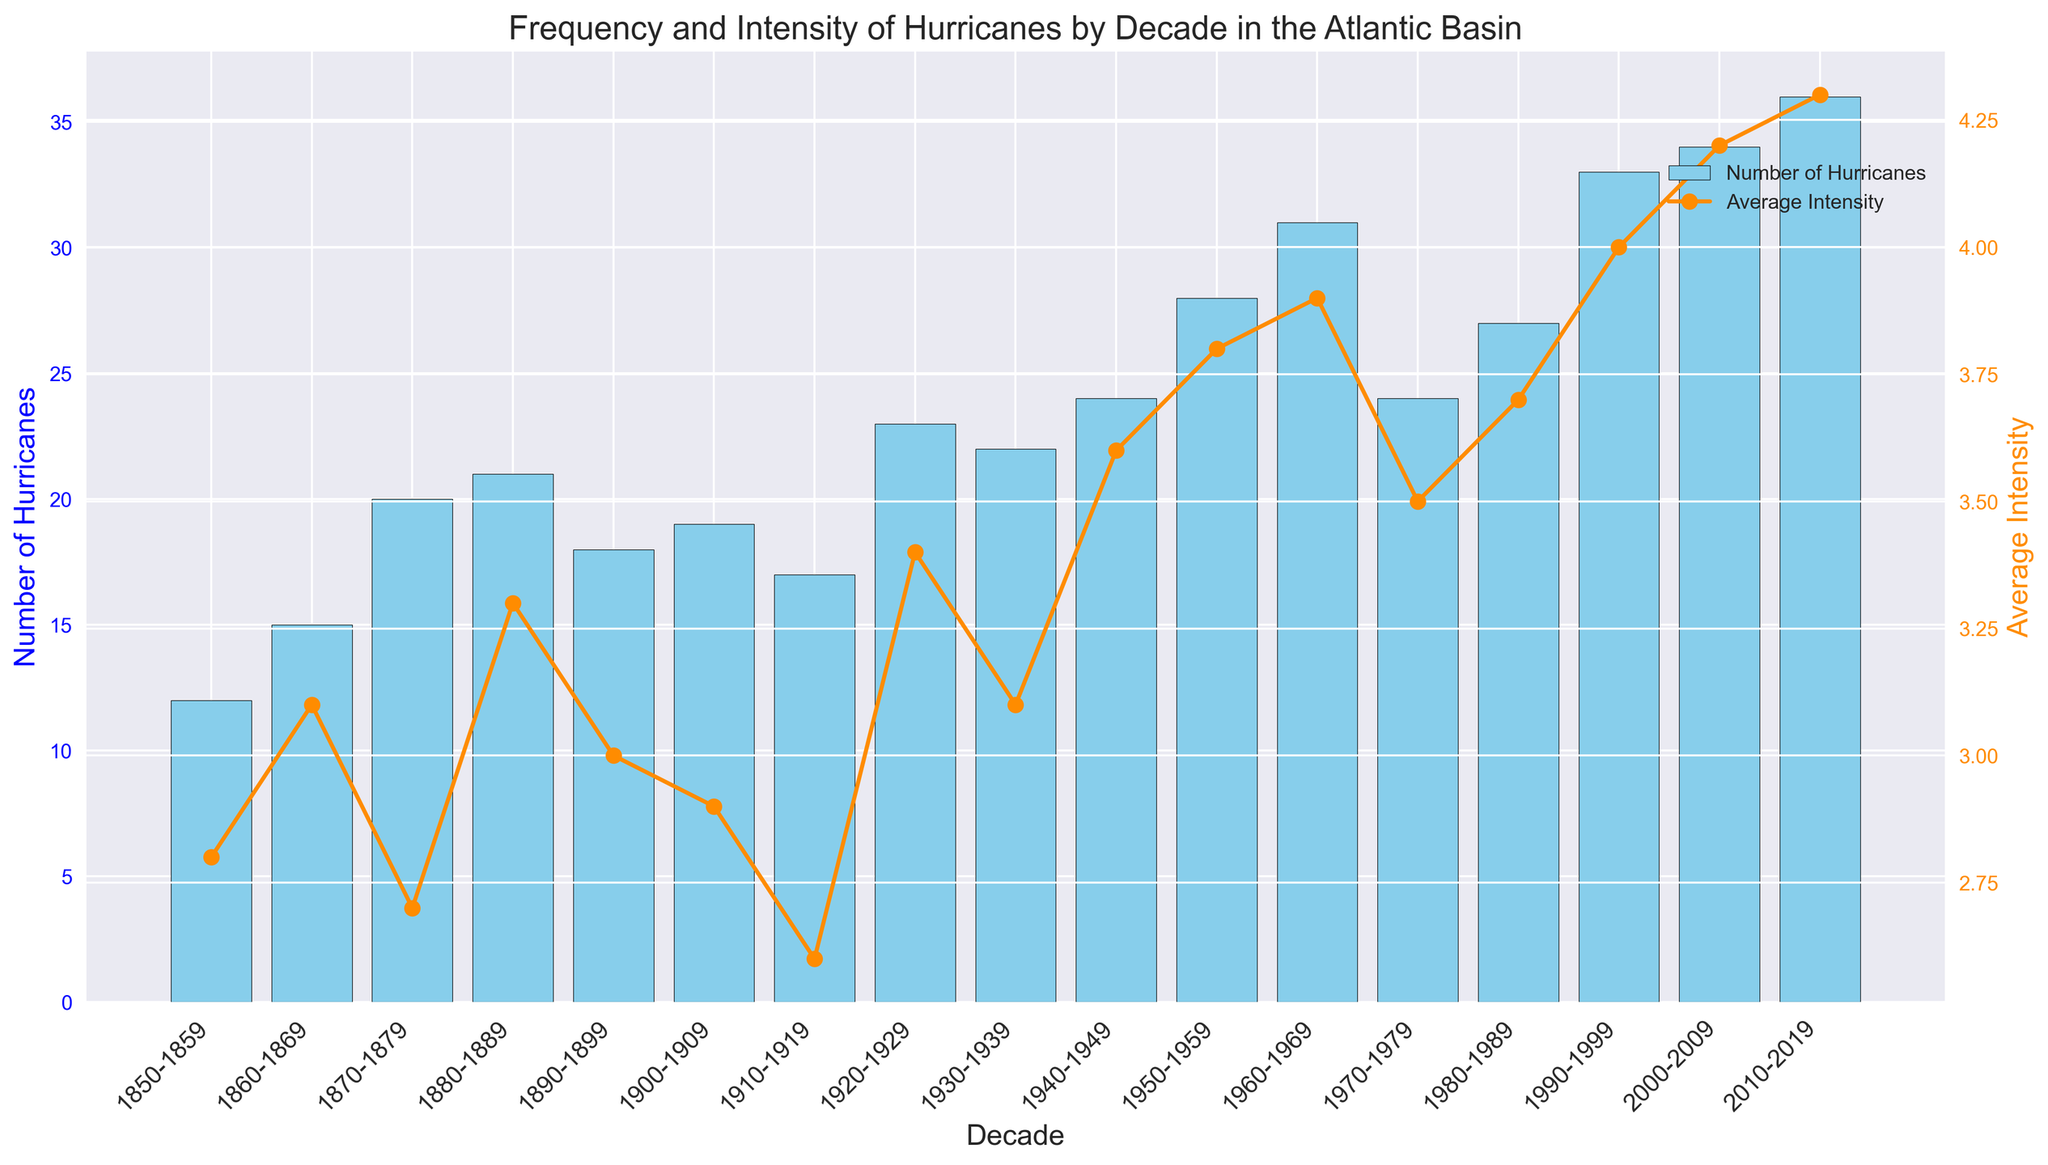What decade had the highest number of hurricanes? By examining the heights of the bars in the figure, the decade with the highest bar will indicate the highest number of hurricanes. The largest bar corresponds to the decade 2010-2019.
Answer: 2010-2019 How many more hurricanes occurred in the decade 2000-2009 compared to 1980-1989? First, locate the bars for the two decades 2000-2009 and 1980-1989. The bar for 2000-2009 corresponds to 34 hurricanes and the bar for 1980-1989 corresponds to 27 hurricanes. Subtract the latter from the former: 34 - 27 = 7
Answer: 7 Which decade shows the most significant increase in average intensity compared to the previous decade? Look at the line plot of average intensity and identify where the steepest increase occurs between decades. The most significant rise is between 1990-1999 and 2000-2009, where the average intensity increases from 4.0 to 4.2.
Answer: 1990-1999 to 2000-2009 Is there a decade where both the number of hurricanes and the average intensity were at or above their respective historical midpoints? To find the midpoints, calculate the mid-range of hurricanes and average intensity. For number of hurricanes, the sequence is 12 to 36, so the midpoint is (12+36)/2 = 24. For intensity, it ranges from 2.6 to 4.3, so the midpoint is (2.6+4.3)/2 = 3.45. The decade 2000-2009 has both 34 hurricanes and an intensity of 4.2, above both midpoints.
Answer: 2000-2009 Between 1950-1959 and 1960-1969, how did the average intensity of hurricanes change? Locate the points corresponding to these decades on the line plot of average intensity. The intensity changes from 3.8 to 3.9. Thus, average intensity increased by 3.9 - 3.8 = 0.1.
Answer: Increased by 0.1 What is the average number of hurricanes per decade from 2000-2019? Identify the number of hurricanes for the decades 2000-2009 and 2010-2019: 34 and 36 respectively. Calculate the average: (34 + 36) / 2 = 35.
Answer: 35 What is the visual difference between the decadal average intensities of hurricanes in 1800-1859 and 2010-2019? By checking the endpoints of the line plot, the average intensities are indicated by lower numbers for 1800-1859 (e.g., ~2.8) and higher for 2010-2019 (4.3). The visual difference shows a noticeable increase, depicted by the upward slope in the line plot.
Answer: Increase How did the number of hurricanes change from 1900-1909 to 1920-1929? The bar for 1900-1909 shows 19 hurricanes and for 1920-1929 shows 23 hurricanes. Calculate the difference: 23 - 19 = 4. So the number increased by 4.
Answer: Increased by 4 Which decade has the highest average intensity? By analyzing the line plot of average intensities, the peak of the line represents the decade with the highest average intensity. This peak occurs at 2010-2019 with an average intensity of 4.3.
Answer: 2010-2019 